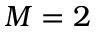<formula> <loc_0><loc_0><loc_500><loc_500>M = 2</formula> 